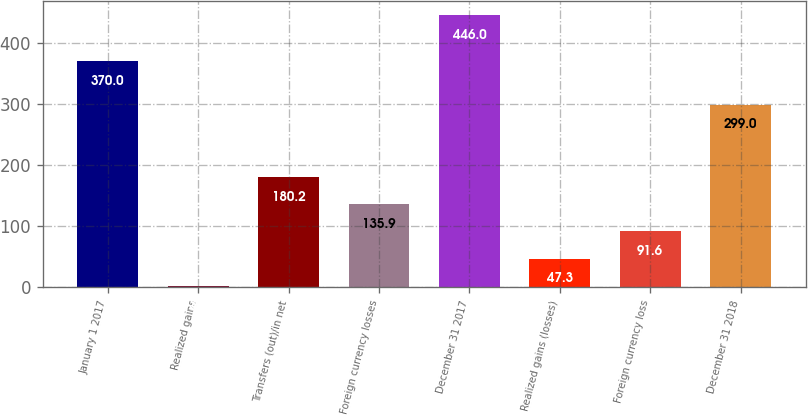Convert chart to OTSL. <chart><loc_0><loc_0><loc_500><loc_500><bar_chart><fcel>January 1 2017<fcel>Realized gains<fcel>Transfers (out)/in net<fcel>Foreign currency losses<fcel>December 31 2017<fcel>Realized gains (losses)<fcel>Foreign currency loss<fcel>December 31 2018<nl><fcel>370<fcel>3<fcel>180.2<fcel>135.9<fcel>446<fcel>47.3<fcel>91.6<fcel>299<nl></chart> 